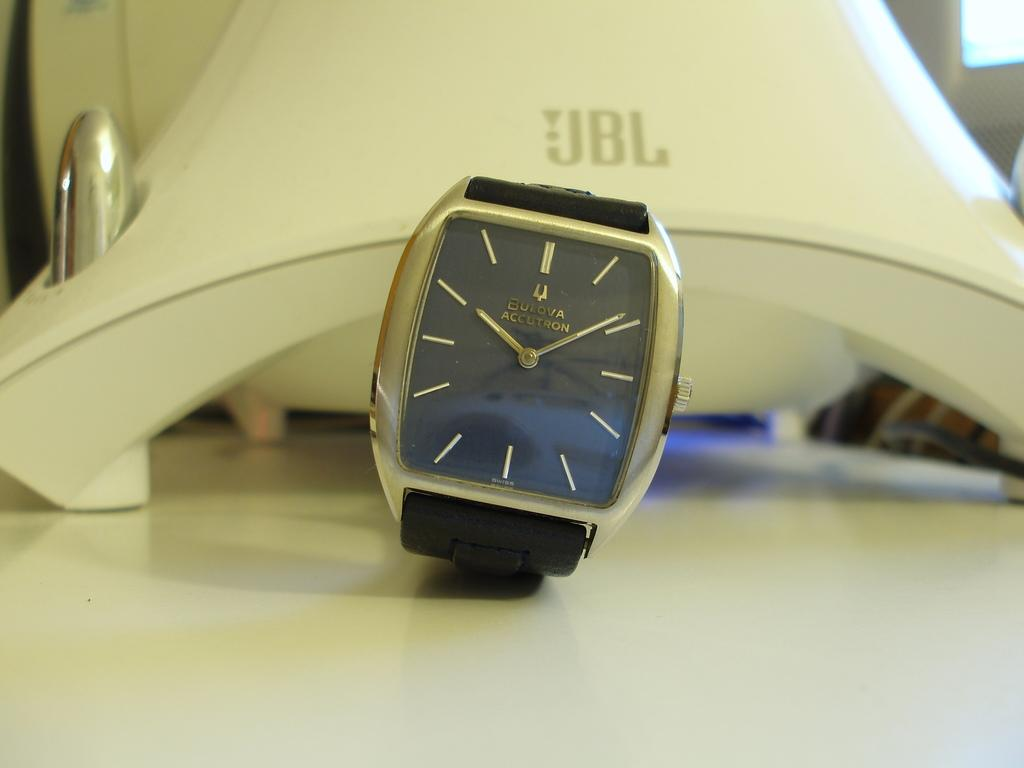Provide a one-sentence caption for the provided image. A new modern watch sitting in front of a JBL speaker. 